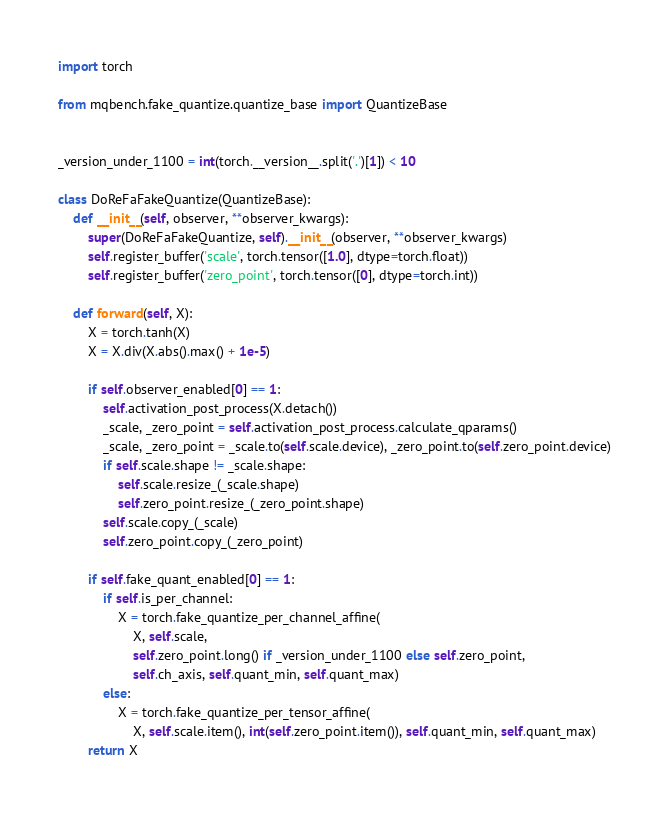<code> <loc_0><loc_0><loc_500><loc_500><_Python_>import torch

from mqbench.fake_quantize.quantize_base import QuantizeBase


_version_under_1100 = int(torch.__version__.split('.')[1]) < 10

class DoReFaFakeQuantize(QuantizeBase):
    def __init__(self, observer, **observer_kwargs):
        super(DoReFaFakeQuantize, self).__init__(observer, **observer_kwargs)
        self.register_buffer('scale', torch.tensor([1.0], dtype=torch.float))
        self.register_buffer('zero_point', torch.tensor([0], dtype=torch.int))

    def forward(self, X):
        X = torch.tanh(X)
        X = X.div(X.abs().max() + 1e-5)

        if self.observer_enabled[0] == 1:
            self.activation_post_process(X.detach())
            _scale, _zero_point = self.activation_post_process.calculate_qparams()
            _scale, _zero_point = _scale.to(self.scale.device), _zero_point.to(self.zero_point.device)
            if self.scale.shape != _scale.shape:
                self.scale.resize_(_scale.shape)
                self.zero_point.resize_(_zero_point.shape)
            self.scale.copy_(_scale)
            self.zero_point.copy_(_zero_point)

        if self.fake_quant_enabled[0] == 1:
            if self.is_per_channel:
                X = torch.fake_quantize_per_channel_affine(
                    X, self.scale, 
                    self.zero_point.long() if _version_under_1100 else self.zero_point,
                    self.ch_axis, self.quant_min, self.quant_max)
            else:
                X = torch.fake_quantize_per_tensor_affine(
                    X, self.scale.item(), int(self.zero_point.item()), self.quant_min, self.quant_max)
        return X</code> 